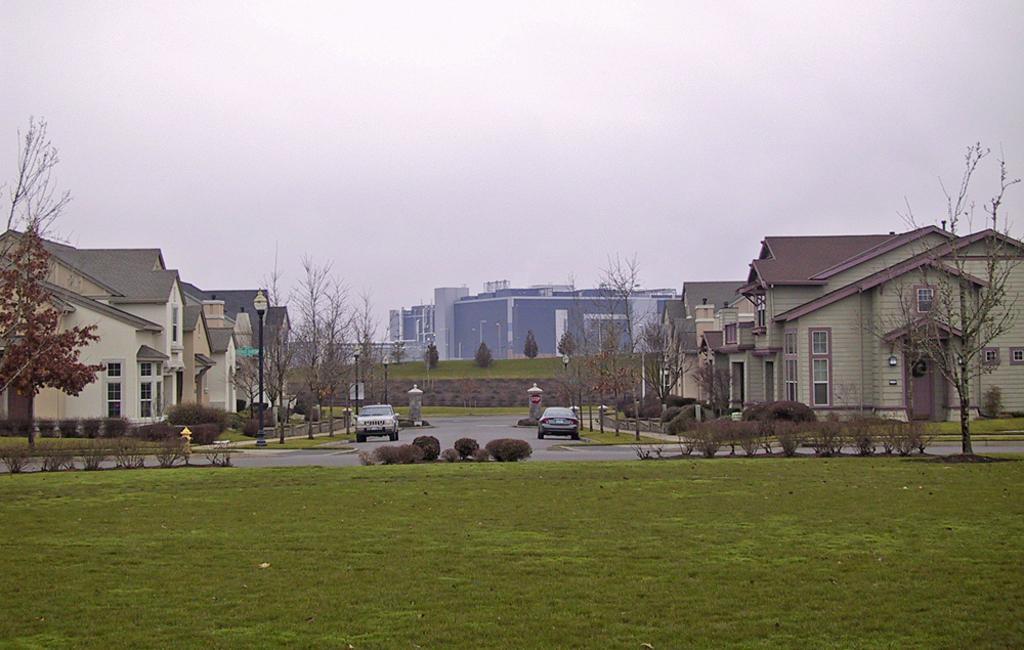In one or two sentences, can you explain what this image depicts? In this picture we can see some grass on the ground. There are bushes, plants, a hydrant, trees, street lights and vehicles on the road. We can see buildings, other objects and the sky. 